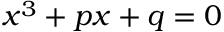Convert formula to latex. <formula><loc_0><loc_0><loc_500><loc_500>x ^ { 3 } + p x + q = 0</formula> 